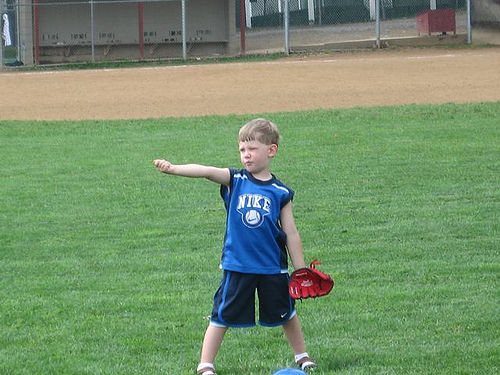Please provide the bounding box coordinate of the region this sentence describes: The boys hair is blonde. The coordinates [0.48, 0.35, 0.60, 0.44] enclose the region of the boy's head, highlighting his blonde hair peeking out from his likely sweat-induced tousled hairstyle. 